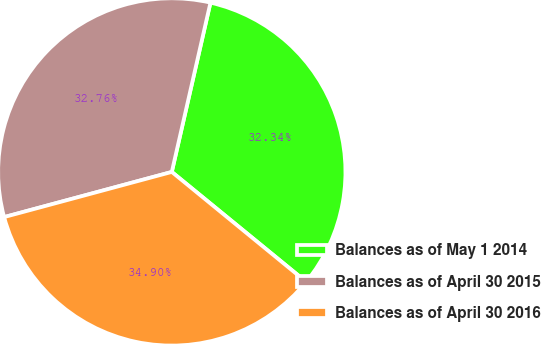Convert chart. <chart><loc_0><loc_0><loc_500><loc_500><pie_chart><fcel>Balances as of May 1 2014<fcel>Balances as of April 30 2015<fcel>Balances as of April 30 2016<nl><fcel>32.34%<fcel>32.76%<fcel>34.9%<nl></chart> 